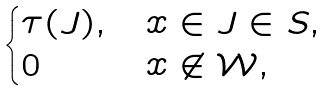<formula> <loc_0><loc_0><loc_500><loc_500>\begin{cases} \tau ( J ) , & x \in J \in S , \\ 0 & x \not \in \mathcal { W } , \end{cases}</formula> 